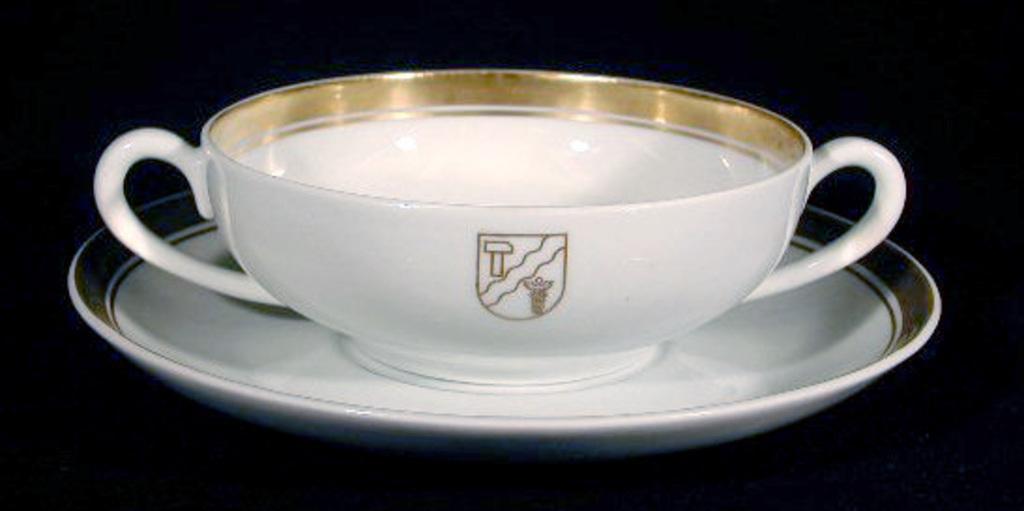How would you summarize this image in a sentence or two? In this picture I can see a cup in the saucer, those are in white color. 